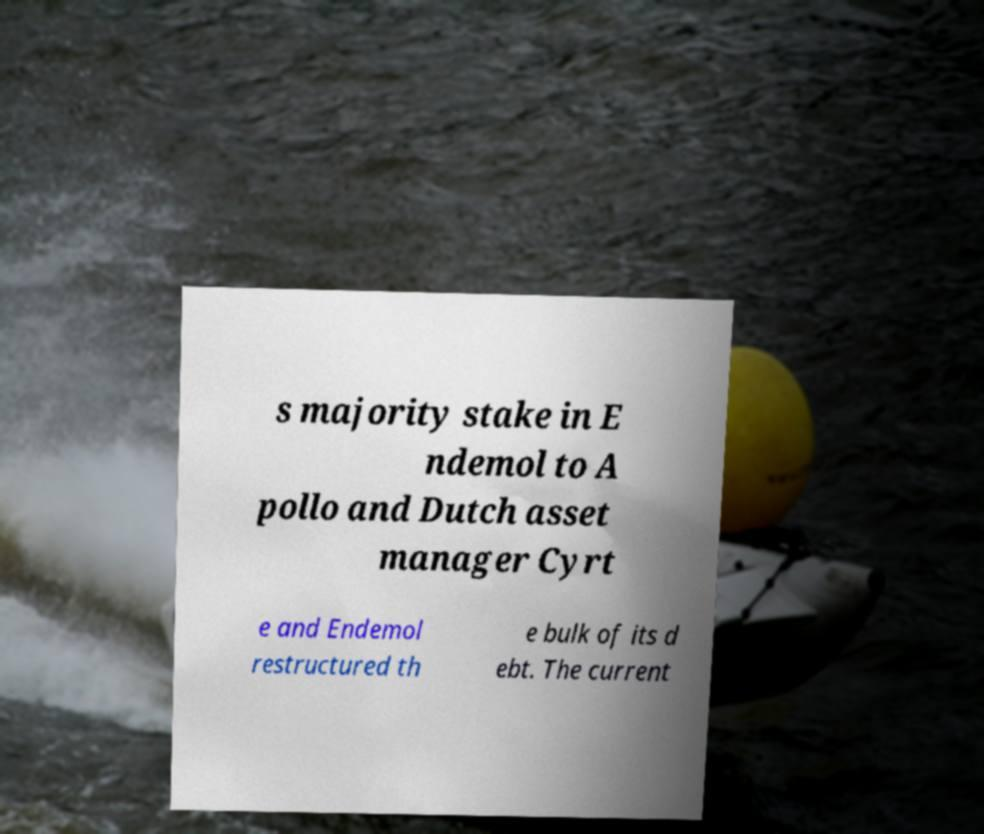Could you assist in decoding the text presented in this image and type it out clearly? s majority stake in E ndemol to A pollo and Dutch asset manager Cyrt e and Endemol restructured th e bulk of its d ebt. The current 